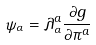<formula> <loc_0><loc_0><loc_500><loc_500>\psi _ { \alpha } = \lambda ^ { a } _ { \alpha } \frac { \partial g } { \partial \pi ^ { a } }</formula> 